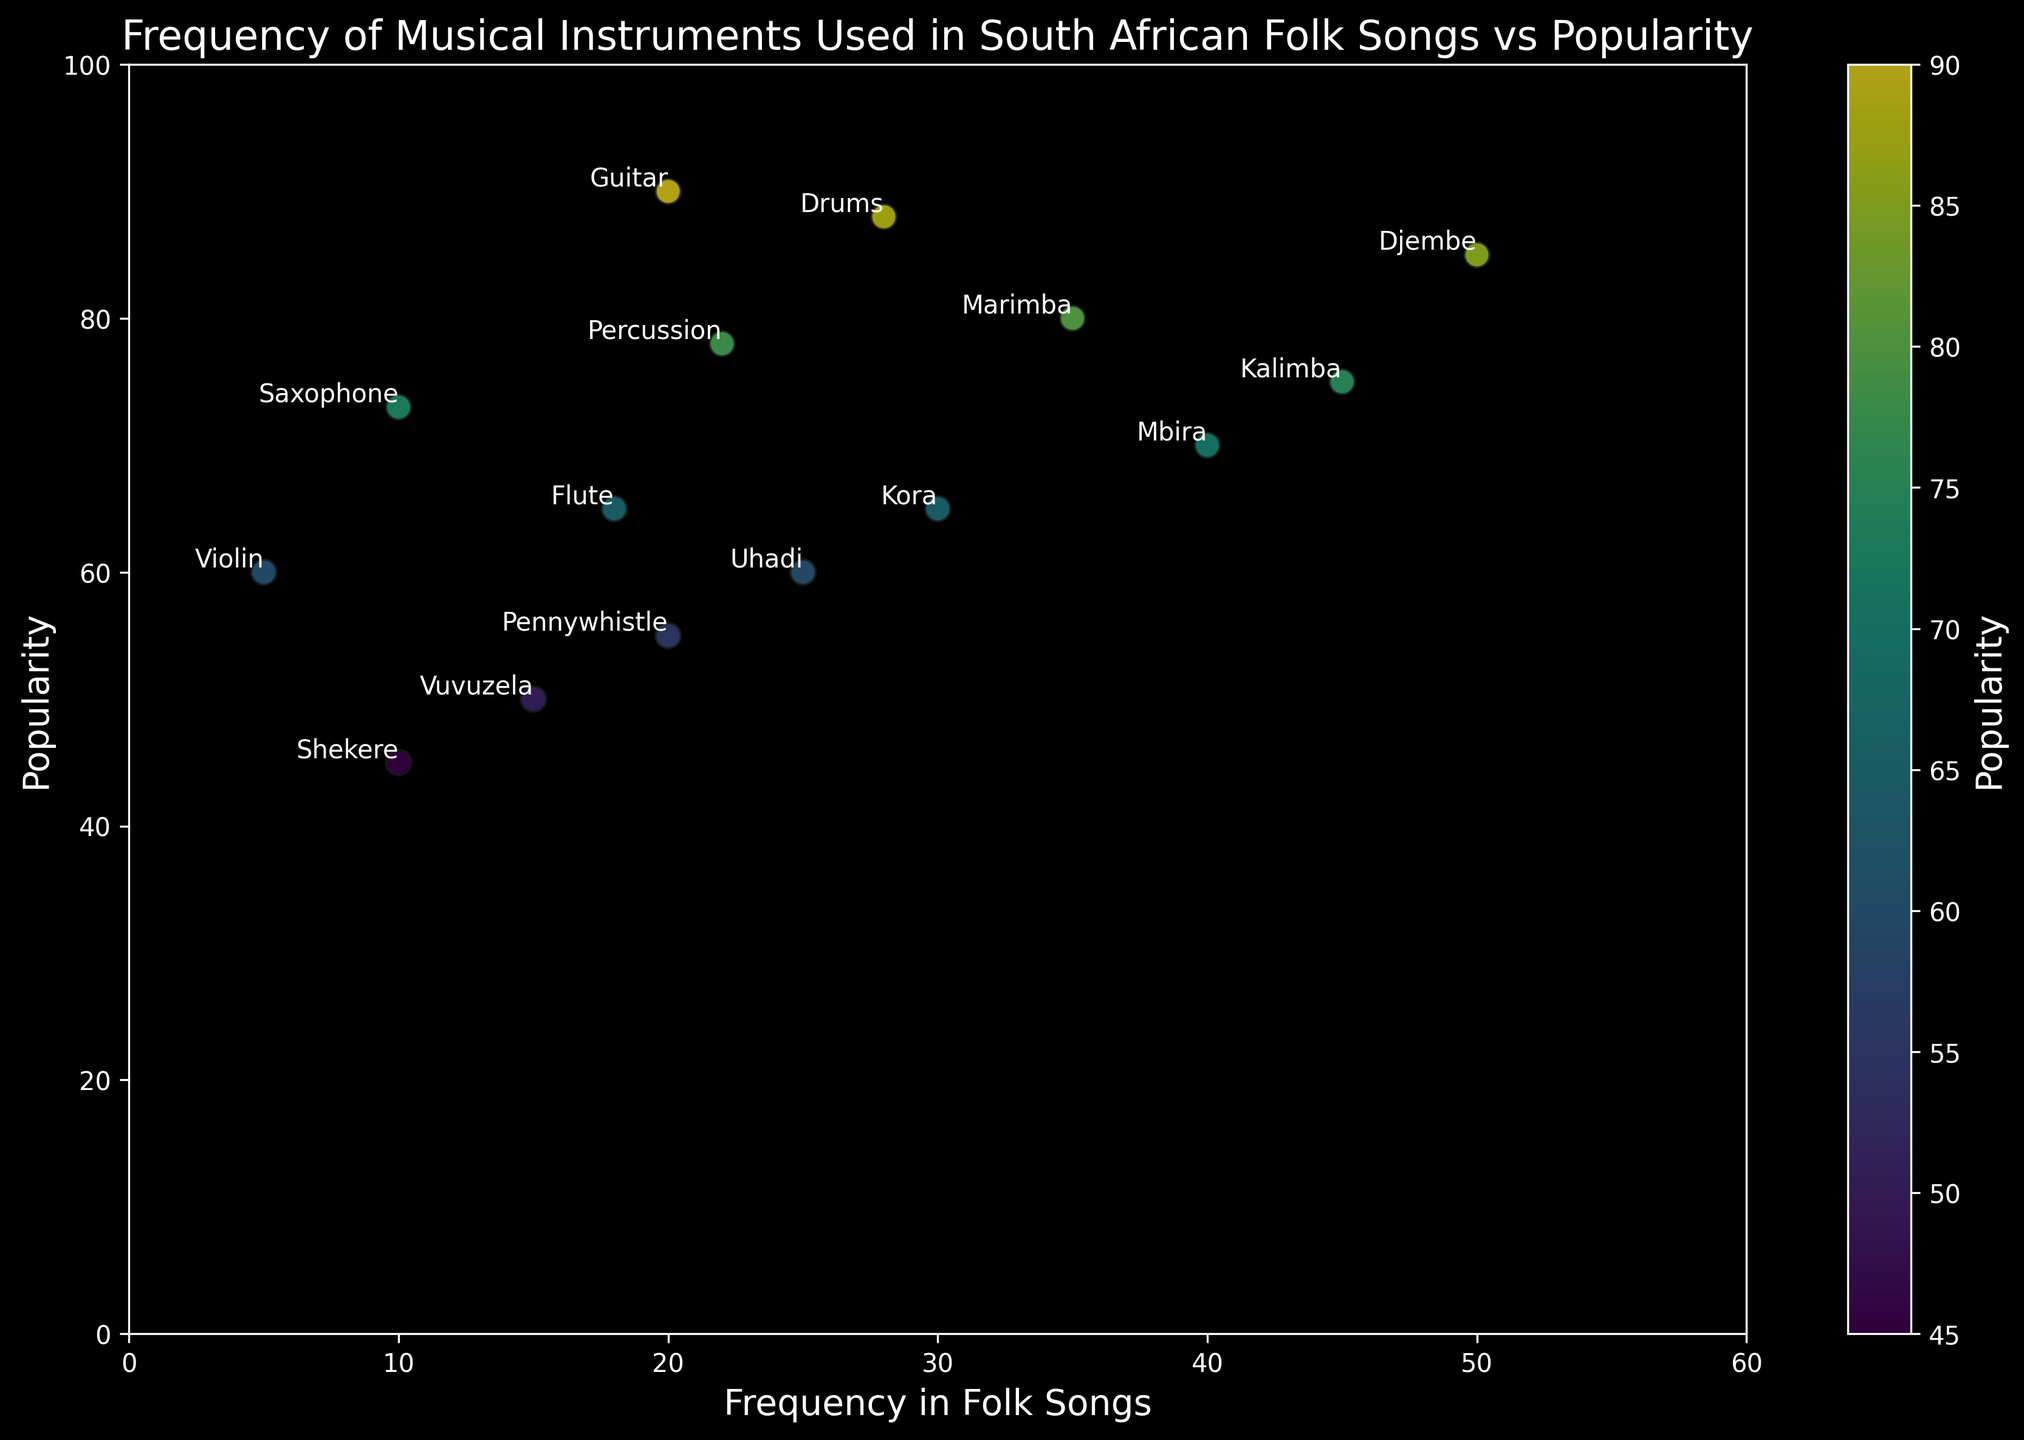Which instrument has the highest popularity? The instrument with the highest y-coordinate represents the highest popularity. In this case, it's the Guitar with a popularity value of 90.
Answer: Guitar How does the frequency of the Marimba compare to that of the Djembe? The x-coordinates represent the frequency in folk songs. The Marimba has a frequency of 35, while the Djembe has a frequency of 50. The Djembe is more frequently used.
Answer: Djembe Which instrument has a frequency close to its popularity value? Compare the x and y values of each instrument. The Uhadi has a frequency of 25 and a popularity of 60, which are closest among all instruments.
Answer: Uhadi What is the sum of the frequencies of the Flute and the Violin? The frequency of the Flute is 18, and the frequency of the Violin is 5. Adding these together gives 18 + 5 = 23.
Answer: 23 Which instrument is more popular: the Mbira or the Kalimba? Compare their y-coordinates. The Mbira has a popularity of 70, and the Kalimba has a popularity of 75. The Kalimba is more popular.
Answer: Kalimba What is the average popularity of the Djembe, Mbira, and Marimba? The popularity values are 85, 70, and 80, respectively. Sum these values (85 + 70 + 80 = 235), and divide by 3 to get the average: 235/3 ≈ 78.3.
Answer: 78.3 Which instrument has the lowest frequency but is still relatively popular (popularity above 60)? Look for the instrument with the lowest x-value with a corresponding y-value above 60. The Violin has a frequency of 5 and a popularity of 60 which fits the criteria.
Answer: Violin How does the popularity of the Vuvuzela compare to the Shekere? Both have low y-values. The Vuvuzela has a popularity of 50, and the Shekere has a popularity of 45. The Vuvuzela is more popular.
Answer: Vuvuzela What is the color gradient's significance in the plot? The color gradient from blue to yellow represents the range of popularity values, with darker colors indicating lower popularity and lighter colors indicating higher popularity.
Answer: Popularity gradient Which instruments have a frequency below 20 and what are their popularities? From the x-values less than 20: Shekere (10, 45), Vuvuzela (15, 50), and Violin (5, 60), and the Flute (18, 65). These have popularities of 45, 50, 60, and 65 respectively.
Answer: Shekere (45), Vuvuzela (50), Violin (60), Flute (65) 